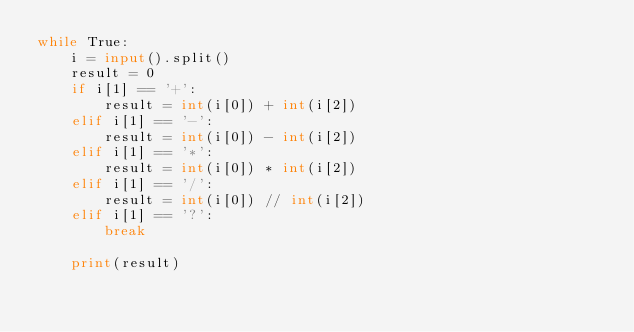<code> <loc_0><loc_0><loc_500><loc_500><_Python_>while True:
    i = input().split()
    result = 0
    if i[1] == '+':
        result = int(i[0]) + int(i[2])
    elif i[1] == '-':
        result = int(i[0]) - int(i[2])
    elif i[1] == '*':
        result = int(i[0]) * int(i[2])
    elif i[1] == '/':
        result = int(i[0]) // int(i[2])
    elif i[1] == '?':
        break

    print(result)</code> 